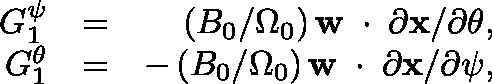Convert formula to latex. <formula><loc_0><loc_0><loc_500><loc_500>\begin{array} { r l r } { G _ { 1 } ^ { \psi } } & { = } & { ( B _ { 0 } / \Omega _ { 0 } ) \, { w } \, \boldmath \cdot \, \partial { x } / \partial \theta , } \\ { G _ { 1 } ^ { \theta } } & { = } & { - \, ( B _ { 0 } / \Omega _ { 0 } ) \, { w } \, \boldmath \cdot \, \partial { x } / \partial \psi , } \end{array}</formula> 